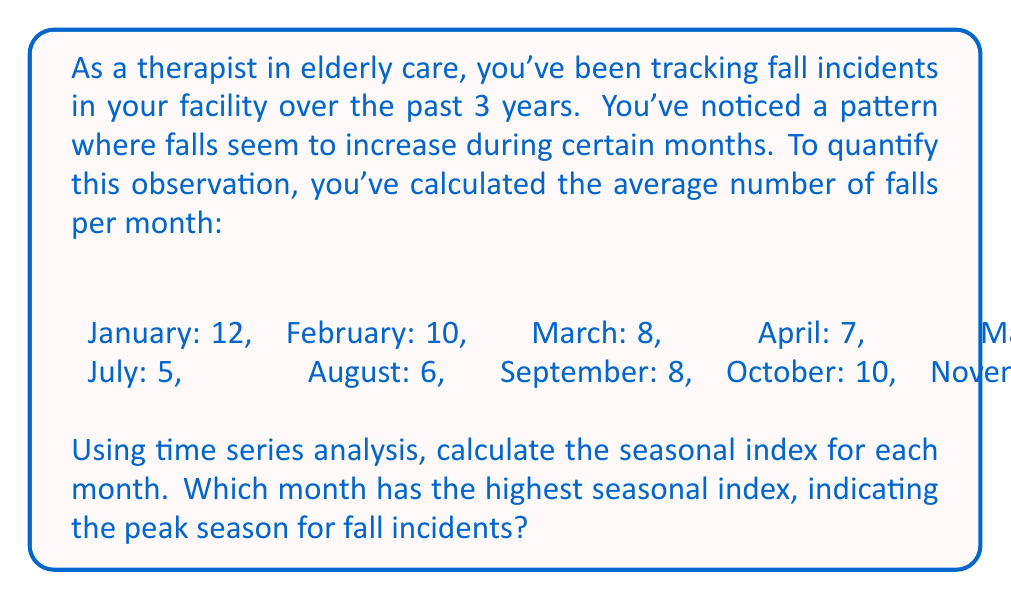Teach me how to tackle this problem. To calculate the seasonal index for each month, we'll follow these steps:

1. Calculate the overall mean of falls per month:
   $\text{Overall Mean} = \frac{\text{Sum of all monthly averages}}{\text{Number of months}}$
   $= \frac{12 + 10 + 8 + 7 + 6 + 5 + 5 + 6 + 8 + 10 + 11 + 12}{12} = \frac{100}{12} = 8.33$

2. Calculate the seasonal index for each month:
   $\text{Seasonal Index} = \frac{\text{Monthly Average}}{\text{Overall Mean}} \times 100$

   January: $\frac{12}{8.33} \times 100 = 144.06$
   February: $\frac{10}{8.33} \times 100 = 120.05$
   March: $\frac{8}{8.33} \times 100 = 96.04$
   April: $\frac{7}{8.33} \times 100 = 84.03$
   May: $\frac{6}{8.33} \times 100 = 72.03$
   June: $\frac{5}{8.33} \times 100 = 60.02$
   July: $\frac{5}{8.33} \times 100 = 60.02$
   August: $\frac{6}{8.33} \times 100 = 72.03$
   September: $\frac{8}{8.33} \times 100 = 96.04$
   October: $\frac{10}{8.33} \times 100 = 120.05$
   November: $\frac{11}{8.33} \times 100 = 132.05$
   December: $\frac{12}{8.33} \times 100 = 144.06$

3. Identify the month with the highest seasonal index.

The highest seasonal index is 144.06, which occurs in both January and December.
Answer: January and December have the highest seasonal index of 144.06, indicating that these are the peak months for fall incidents among the elderly in the care facility. 